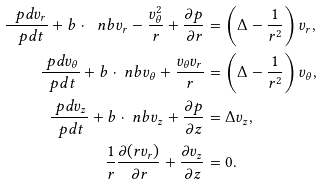<formula> <loc_0><loc_0><loc_500><loc_500>\frac { \ p d v _ { r } } { \ p d t } + b \cdot \ n b v _ { r } - \frac { v _ { \theta } ^ { 2 } } { r } + \frac { \partial p } { \partial r } & = \left ( \Delta - \frac { 1 } { r ^ { 2 } } \right ) v _ { r } , \\ \frac { \ p d v _ { \theta } } { \ p d t } + b \cdot \ n b v _ { \theta } + \frac { v _ { \theta } v _ { r } } { r } & = \left ( \Delta - \frac { 1 } { r ^ { 2 } } \right ) v _ { \theta } , \\ \frac { \ p d v _ { z } } { \ p d t } + b \cdot \ n b v _ { z } + \frac { \partial p } { \partial z } & = \Delta v _ { z } , \\ \frac { 1 } { r } \frac { \partial ( r v _ { r } ) } { \partial r } + \frac { \partial v _ { z } } { \partial z } & = 0 .</formula> 